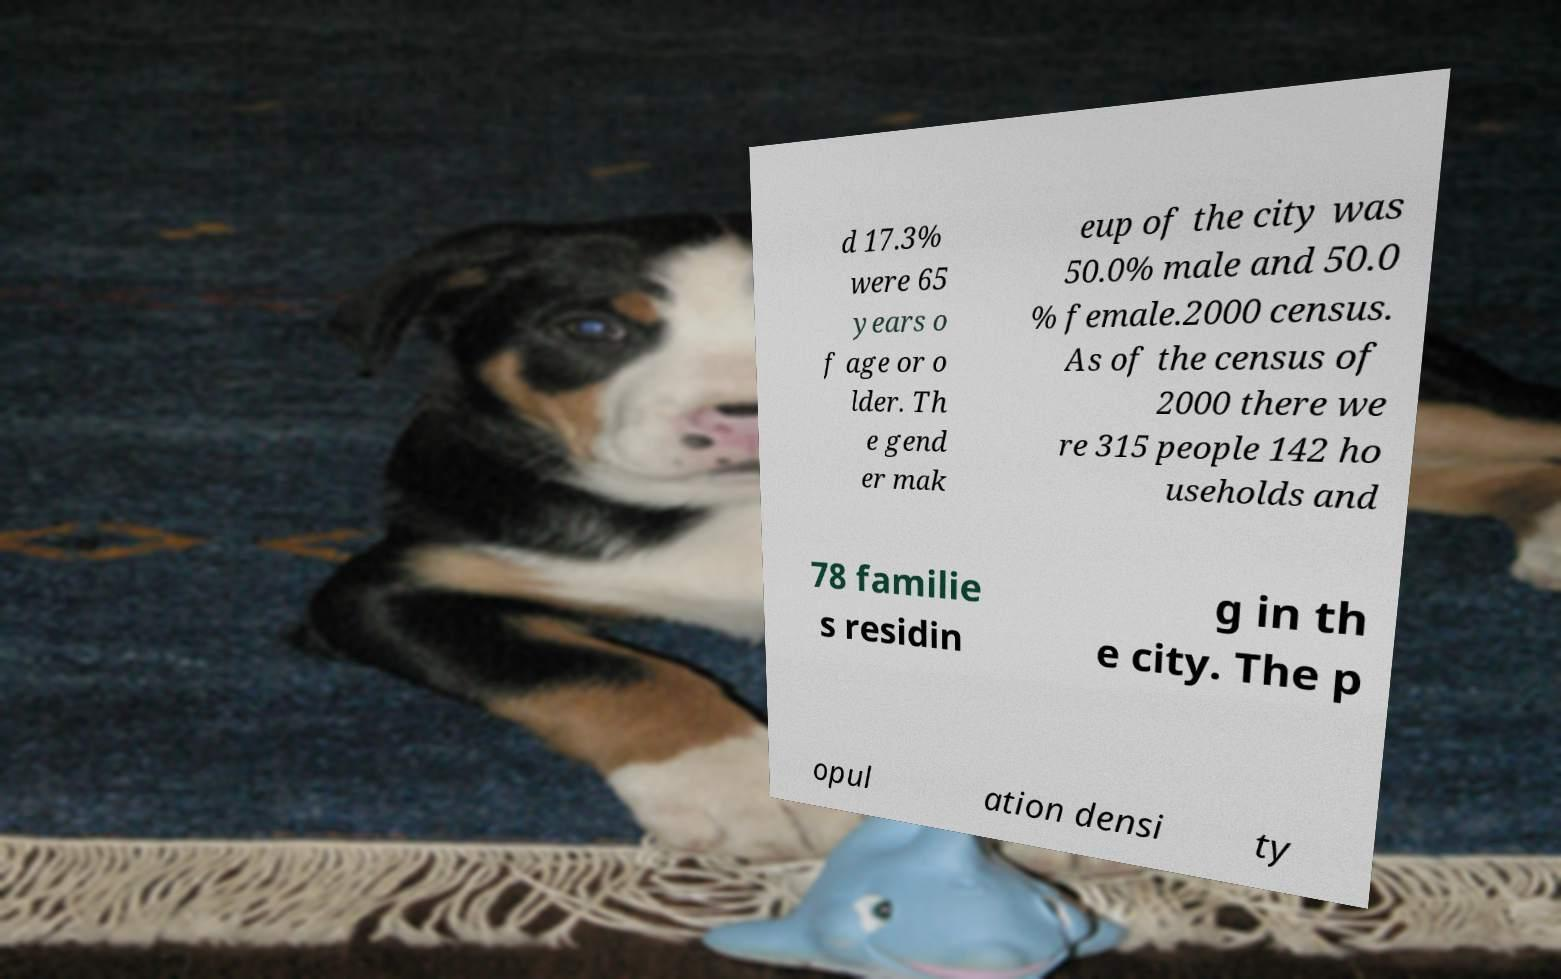Can you accurately transcribe the text from the provided image for me? d 17.3% were 65 years o f age or o lder. Th e gend er mak eup of the city was 50.0% male and 50.0 % female.2000 census. As of the census of 2000 there we re 315 people 142 ho useholds and 78 familie s residin g in th e city. The p opul ation densi ty 